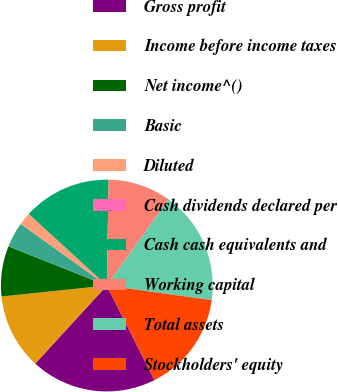Convert chart to OTSL. <chart><loc_0><loc_0><loc_500><loc_500><pie_chart><fcel>Gross profit<fcel>Income before income taxes<fcel>Net income^()<fcel>Basic<fcel>Diluted<fcel>Cash dividends declared per<fcel>Cash cash equivalents and<fcel>Working capital<fcel>Total assets<fcel>Stockholders' equity<nl><fcel>19.23%<fcel>11.54%<fcel>7.69%<fcel>3.85%<fcel>1.92%<fcel>0.0%<fcel>13.46%<fcel>9.62%<fcel>17.31%<fcel>15.38%<nl></chart> 